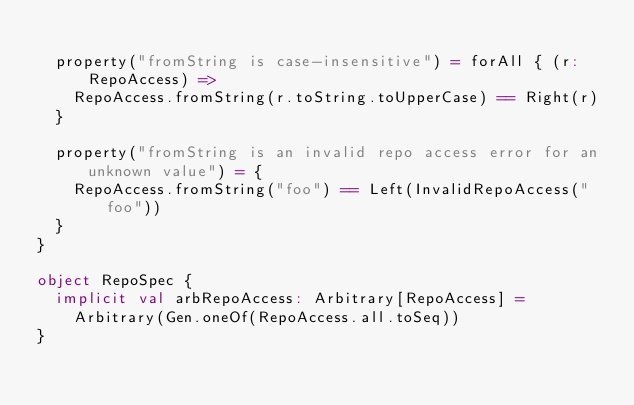Convert code to text. <code><loc_0><loc_0><loc_500><loc_500><_Scala_>
  property("fromString is case-insensitive") = forAll { (r: RepoAccess) =>
    RepoAccess.fromString(r.toString.toUpperCase) == Right(r)
  }

  property("fromString is an invalid repo access error for an unknown value") = {
    RepoAccess.fromString("foo") == Left(InvalidRepoAccess("foo"))
  }
}

object RepoSpec {
  implicit val arbRepoAccess: Arbitrary[RepoAccess] =
    Arbitrary(Gen.oneOf(RepoAccess.all.toSeq))
}
</code> 